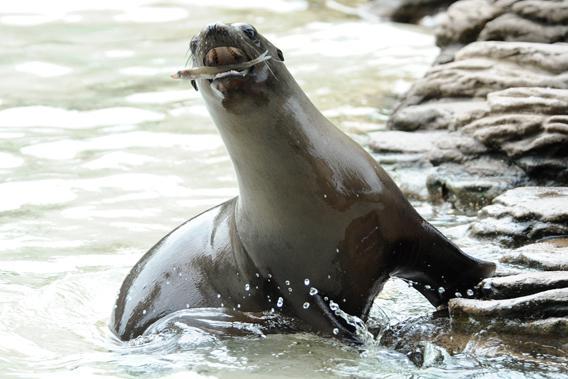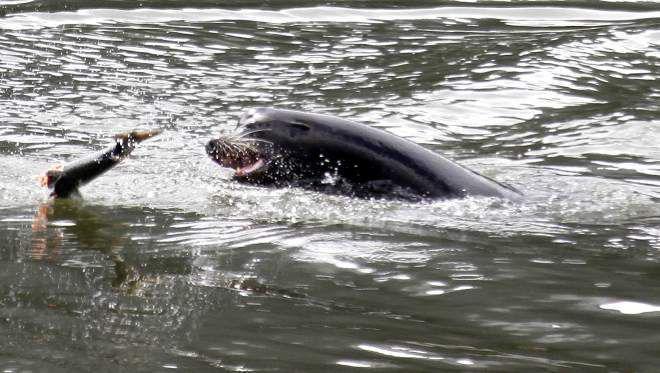The first image is the image on the left, the second image is the image on the right. Considering the images on both sides, is "Each image shows one dark seal with its head showing above water, and in at least one image, the seal is chewing on torn orange-fleshed fish." valid? Answer yes or no. No. 